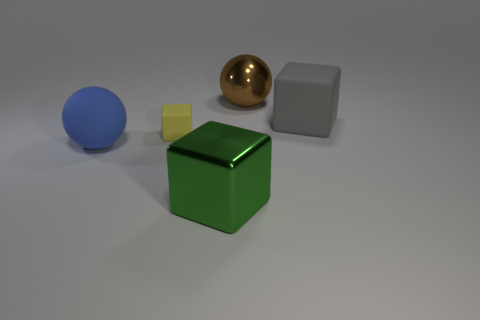Are there more brown spheres in front of the green cube than blue matte objects behind the tiny thing?
Your answer should be compact. No. There is a rubber thing that is right of the small yellow matte thing; is its color the same as the tiny rubber block?
Make the answer very short. No. Is there anything else that is the same color as the big metallic ball?
Give a very brief answer. No. Is the number of green metal objects that are to the left of the small thing greater than the number of large metal blocks?
Provide a short and direct response. No. Do the metallic cube and the blue matte ball have the same size?
Provide a succinct answer. Yes. What material is the green thing that is the same shape as the small yellow object?
Your answer should be compact. Metal. What number of gray objects are rubber spheres or big matte blocks?
Your answer should be very brief. 1. What is the material of the big cube behind the small object?
Offer a terse response. Rubber. Is the number of small yellow things greater than the number of blocks?
Make the answer very short. No. There is a shiny object on the right side of the green object; does it have the same shape as the gray rubber object?
Provide a succinct answer. No. 